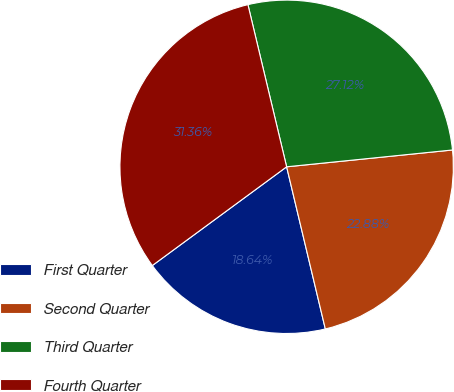<chart> <loc_0><loc_0><loc_500><loc_500><pie_chart><fcel>First Quarter<fcel>Second Quarter<fcel>Third Quarter<fcel>Fourth Quarter<nl><fcel>18.64%<fcel>22.88%<fcel>27.12%<fcel>31.36%<nl></chart> 